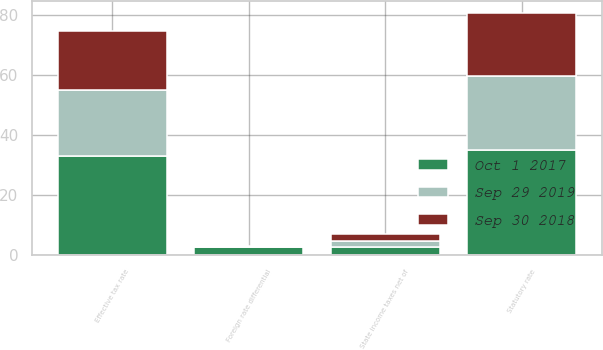Convert chart to OTSL. <chart><loc_0><loc_0><loc_500><loc_500><stacked_bar_chart><ecel><fcel>Statutory rate<fcel>State income taxes net of<fcel>Foreign rate differential<fcel>Effective tax rate<nl><fcel>Sep 30 2018<fcel>21<fcel>2.1<fcel>0.1<fcel>19.5<nl><fcel>Sep 29 2019<fcel>24.5<fcel>2.1<fcel>0.1<fcel>21.8<nl><fcel>Oct 1 2017<fcel>35<fcel>2.8<fcel>2.8<fcel>33.2<nl></chart> 